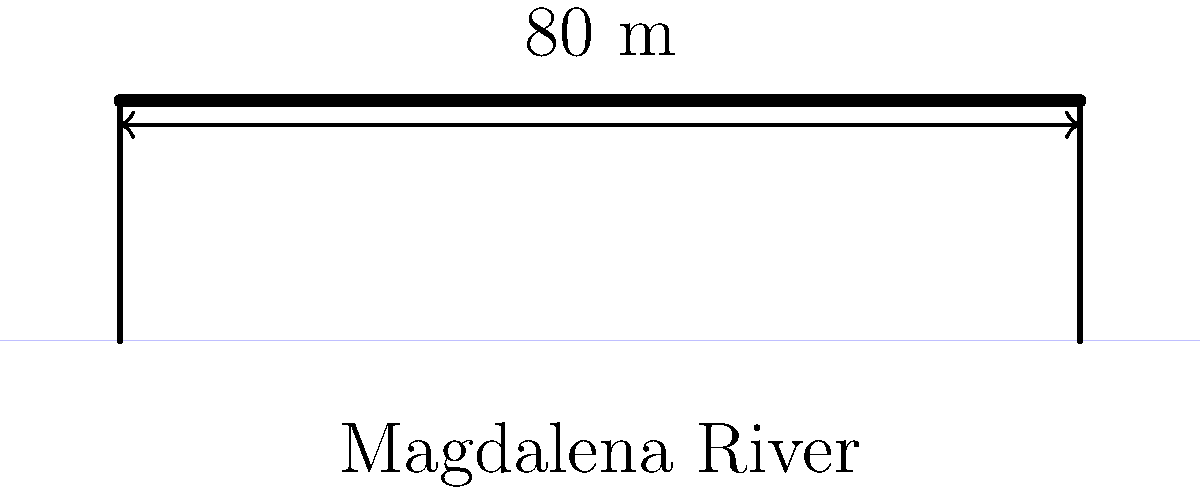A new bridge is being designed to span the Magdalena River near Barranquilla, inspired by the engineering prowess of Colombian engineer Sofía Osío. The bridge will have a simple supported span of 80 meters. If the maximum allowable bending stress in the steel girders is 165 MPa and the moment of inertia of the girder cross-section is $2.5 \times 10^{-2} \text{ m}^4$, what is the maximum uniformly distributed load (in kN/m) that can be safely supported by the bridge? Let's approach this step-by-step:

1) For a simply supported beam with uniformly distributed load, the maximum bending moment occurs at the center and is given by:

   $$M_{max} = \frac{wL^2}{8}$$

   where $w$ is the uniformly distributed load and $L$ is the span length.

2) The bending stress formula is:

   $$\sigma = \frac{My}{I}$$

   where $\sigma$ is the bending stress, $M$ is the bending moment, $y$ is the distance from the neutral axis to the extreme fiber, and $I$ is the moment of inertia.

3) At the maximum allowable stress, we can equate these:

   $$\sigma_{max} = \frac{M_{max}y}{I} = \frac{wL^2y}{8I}$$

4) Rearranging to solve for $w$:

   $$w = \frac{8\sigma_{max}I}{L^2y}$$

5) We know:
   - $\sigma_{max} = 165 \text{ MPa} = 165 \times 10^6 \text{ Pa}$
   - $I = 2.5 \times 10^{-2} \text{ m}^4$
   - $L = 80 \text{ m}$
   - We don't know $y$, but for a typical I-beam, $y$ is approximately half the beam depth. Let's assume $y = 0.5 \text{ m}$.

6) Plugging in the values:

   $$w = \frac{8 \times (165 \times 10^6) \times (2.5 \times 10^{-2})}{80^2 \times 0.5} = 25,781.25 \text{ N/m} = 25.78 \text{ kN/m}$$

Therefore, the maximum uniformly distributed load that can be safely supported is approximately 25.78 kN/m.
Answer: 25.78 kN/m 